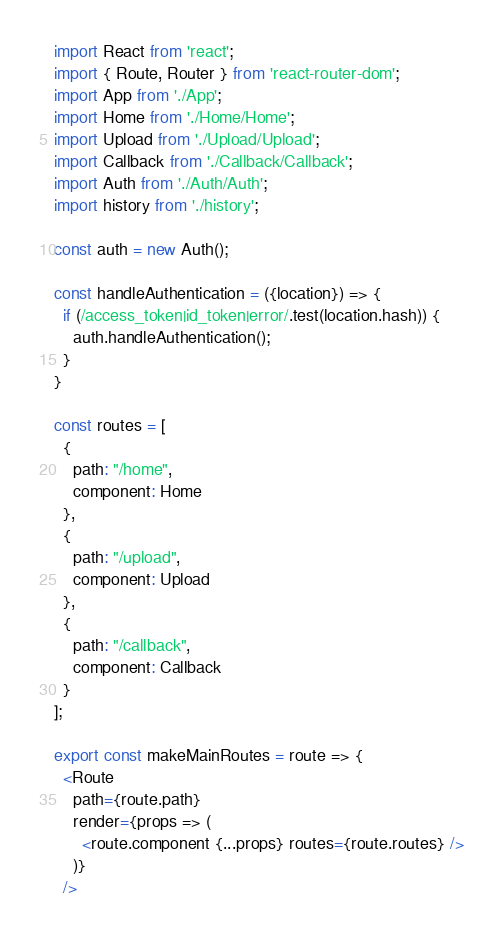Convert code to text. <code><loc_0><loc_0><loc_500><loc_500><_JavaScript_>import React from 'react';
import { Route, Router } from 'react-router-dom';
import App from './App';
import Home from './Home/Home';
import Upload from './Upload/Upload';
import Callback from './Callback/Callback';
import Auth from './Auth/Auth';
import history from './history';

const auth = new Auth();

const handleAuthentication = ({location}) => {
  if (/access_token|id_token|error/.test(location.hash)) {
    auth.handleAuthentication();
  }
}

const routes = [
  {
    path: "/home",
    component: Home
  },
  {
    path: "/upload",
    component: Upload
  },
  {
    path: "/callback",
    component: Callback
  }
];

export const makeMainRoutes = route => {
  <Route
    path={route.path}
    render={props => (
      <route.component {...props} routes={route.routes} />
    )}
  />
</code> 